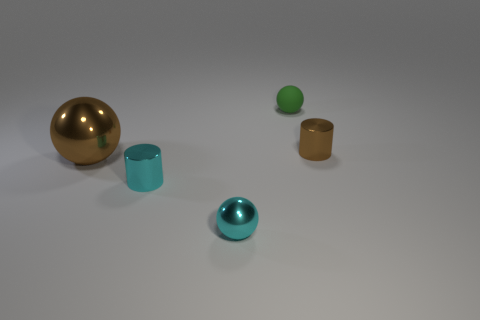How does the texture of the objects differ? The objects exhibit a variety of textures. The large gold sphere and the blue teal sphere have a reflective glossy texture, while the small green sphere and the two cylindrical objects have a matte finish, diffusing light rather than reflecting it. 